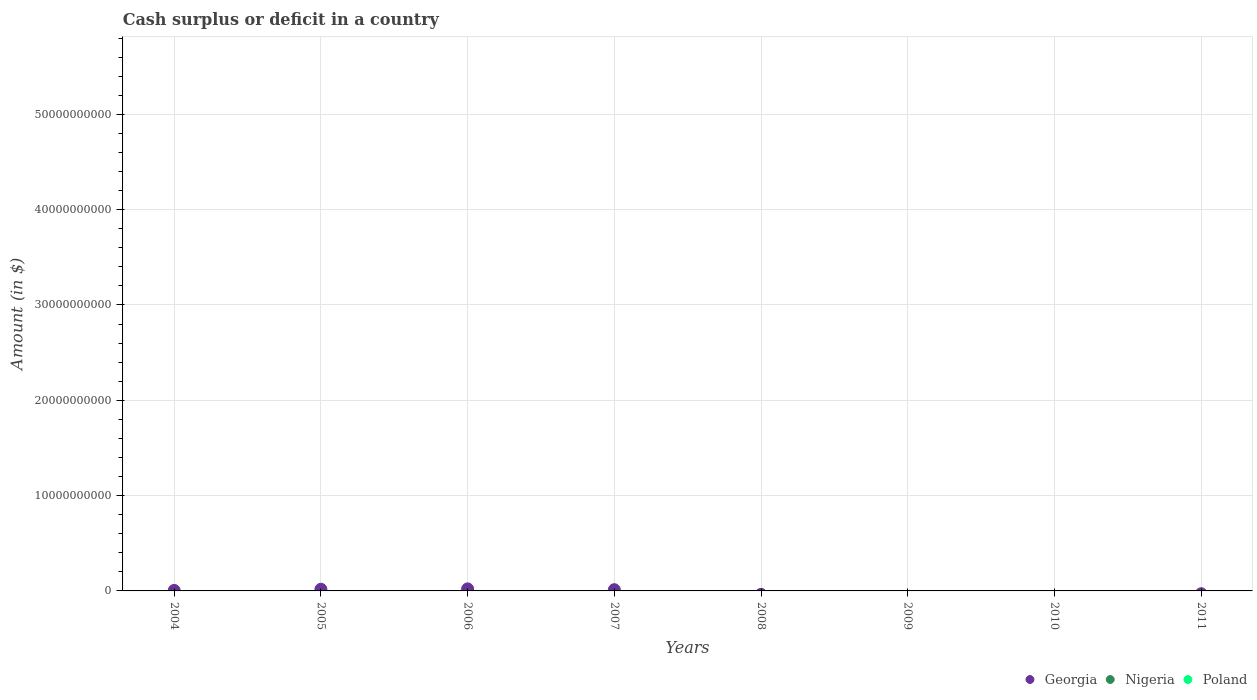How many different coloured dotlines are there?
Ensure brevity in your answer.  1. Is the number of dotlines equal to the number of legend labels?
Provide a short and direct response. No. What is the amount of cash surplus or deficit in Poland in 2011?
Offer a terse response. 0. Across all years, what is the maximum amount of cash surplus or deficit in Georgia?
Your answer should be very brief. 2.14e+08. What is the difference between the amount of cash surplus or deficit in Georgia in 2004 and that in 2007?
Provide a succinct answer. -7.70e+07. What is the difference between the amount of cash surplus or deficit in Poland in 2004 and the amount of cash surplus or deficit in Georgia in 2005?
Ensure brevity in your answer.  -1.77e+08. What is the average amount of cash surplus or deficit in Poland per year?
Offer a terse response. 0. What is the difference between the highest and the second highest amount of cash surplus or deficit in Georgia?
Your response must be concise. 3.73e+07. What is the difference between the highest and the lowest amount of cash surplus or deficit in Georgia?
Your answer should be compact. 2.14e+08. In how many years, is the amount of cash surplus or deficit in Nigeria greater than the average amount of cash surplus or deficit in Nigeria taken over all years?
Make the answer very short. 0. Is the amount of cash surplus or deficit in Georgia strictly greater than the amount of cash surplus or deficit in Nigeria over the years?
Give a very brief answer. Yes. Is the amount of cash surplus or deficit in Poland strictly less than the amount of cash surplus or deficit in Nigeria over the years?
Give a very brief answer. No. How many years are there in the graph?
Provide a succinct answer. 8. What is the difference between two consecutive major ticks on the Y-axis?
Give a very brief answer. 1.00e+1. Does the graph contain any zero values?
Make the answer very short. Yes. Does the graph contain grids?
Ensure brevity in your answer.  Yes. Where does the legend appear in the graph?
Give a very brief answer. Bottom right. How are the legend labels stacked?
Offer a very short reply. Horizontal. What is the title of the graph?
Ensure brevity in your answer.  Cash surplus or deficit in a country. What is the label or title of the X-axis?
Ensure brevity in your answer.  Years. What is the label or title of the Y-axis?
Give a very brief answer. Amount (in $). What is the Amount (in $) in Georgia in 2004?
Give a very brief answer. 5.26e+07. What is the Amount (in $) in Nigeria in 2004?
Offer a terse response. 0. What is the Amount (in $) in Georgia in 2005?
Provide a succinct answer. 1.77e+08. What is the Amount (in $) of Poland in 2005?
Offer a terse response. 0. What is the Amount (in $) in Georgia in 2006?
Your answer should be compact. 2.14e+08. What is the Amount (in $) in Georgia in 2007?
Keep it short and to the point. 1.30e+08. What is the Amount (in $) of Nigeria in 2007?
Keep it short and to the point. 0. What is the Amount (in $) of Poland in 2007?
Your answer should be compact. 0. What is the Amount (in $) of Georgia in 2008?
Give a very brief answer. 0. What is the Amount (in $) of Poland in 2008?
Provide a succinct answer. 0. What is the Amount (in $) of Nigeria in 2009?
Your answer should be very brief. 0. What is the Amount (in $) of Georgia in 2010?
Offer a terse response. 0. What is the Amount (in $) of Nigeria in 2010?
Make the answer very short. 0. What is the Amount (in $) of Georgia in 2011?
Give a very brief answer. 0. What is the Amount (in $) in Nigeria in 2011?
Your response must be concise. 0. What is the Amount (in $) of Poland in 2011?
Provide a short and direct response. 0. Across all years, what is the maximum Amount (in $) in Georgia?
Give a very brief answer. 2.14e+08. Across all years, what is the minimum Amount (in $) of Georgia?
Keep it short and to the point. 0. What is the total Amount (in $) in Georgia in the graph?
Keep it short and to the point. 5.74e+08. What is the difference between the Amount (in $) of Georgia in 2004 and that in 2005?
Your response must be concise. -1.25e+08. What is the difference between the Amount (in $) of Georgia in 2004 and that in 2006?
Your answer should be compact. -1.62e+08. What is the difference between the Amount (in $) in Georgia in 2004 and that in 2007?
Your answer should be very brief. -7.70e+07. What is the difference between the Amount (in $) of Georgia in 2005 and that in 2006?
Your answer should be very brief. -3.73e+07. What is the difference between the Amount (in $) of Georgia in 2005 and that in 2007?
Give a very brief answer. 4.76e+07. What is the difference between the Amount (in $) in Georgia in 2006 and that in 2007?
Give a very brief answer. 8.49e+07. What is the average Amount (in $) of Georgia per year?
Offer a very short reply. 7.17e+07. What is the ratio of the Amount (in $) in Georgia in 2004 to that in 2005?
Ensure brevity in your answer.  0.3. What is the ratio of the Amount (in $) in Georgia in 2004 to that in 2006?
Keep it short and to the point. 0.25. What is the ratio of the Amount (in $) in Georgia in 2004 to that in 2007?
Offer a terse response. 0.41. What is the ratio of the Amount (in $) of Georgia in 2005 to that in 2006?
Make the answer very short. 0.83. What is the ratio of the Amount (in $) of Georgia in 2005 to that in 2007?
Your answer should be compact. 1.37. What is the ratio of the Amount (in $) in Georgia in 2006 to that in 2007?
Your answer should be compact. 1.66. What is the difference between the highest and the second highest Amount (in $) in Georgia?
Provide a succinct answer. 3.73e+07. What is the difference between the highest and the lowest Amount (in $) in Georgia?
Your answer should be compact. 2.14e+08. 